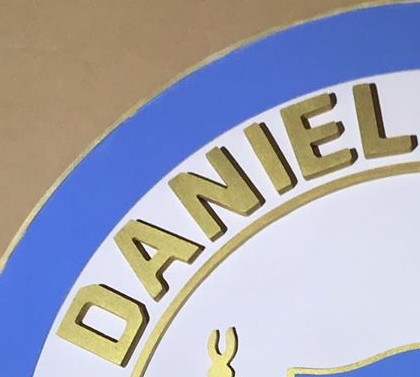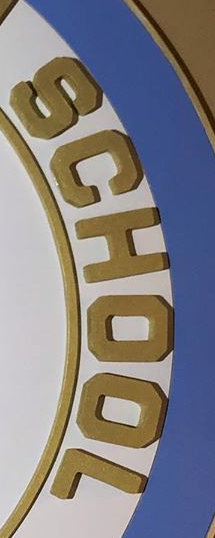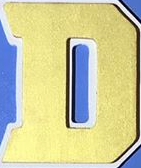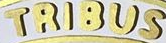What words can you see in these images in sequence, separated by a semicolon? DANIEL; SCHOOL; D; TRIBUS 